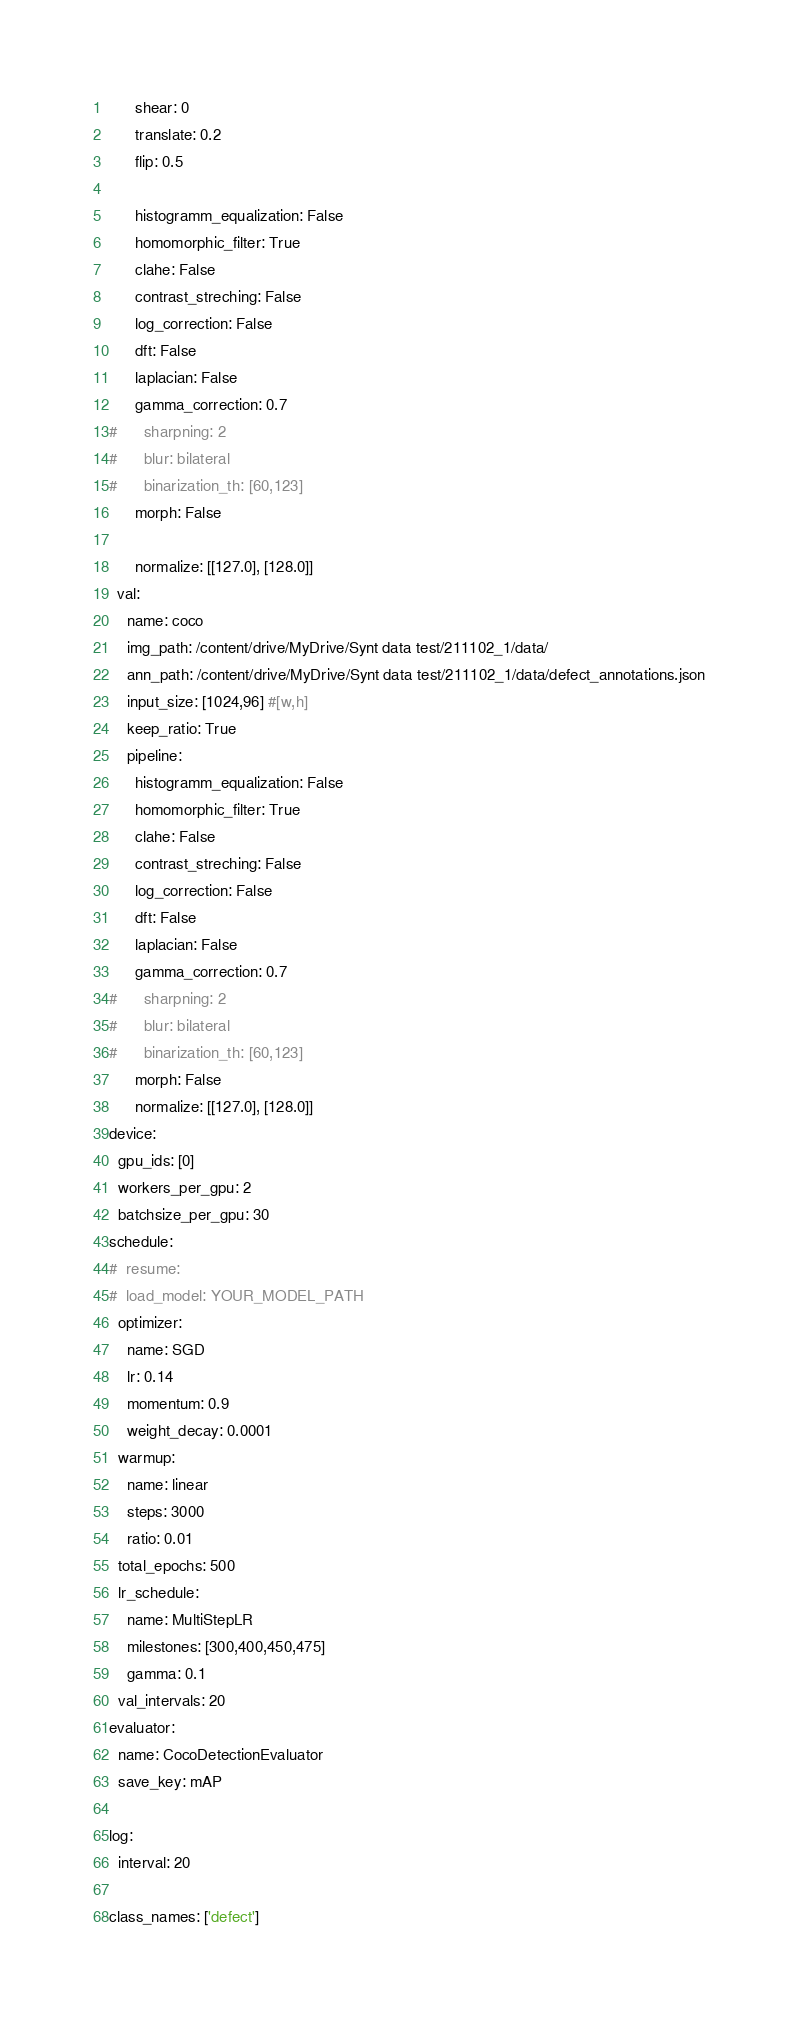Convert code to text. <code><loc_0><loc_0><loc_500><loc_500><_YAML_>      shear: 0
      translate: 0.2
      flip: 0.5
      
      histogramm_equalization: False
      homomorphic_filter: True
      clahe: False
      contrast_streching: False
      log_correction: False
      dft: False
      laplacian: False
      gamma_correction: 0.7
#      sharpning: 2
#      blur: bilateral
#      binarization_th: [60,123]
      morph: False

      normalize: [[127.0], [128.0]]
  val:
    name: coco
    img_path: /content/drive/MyDrive/Synt data test/211102_1/data/
    ann_path: /content/drive/MyDrive/Synt data test/211102_1/data/defect_annotations.json
    input_size: [1024,96] #[w,h]
    keep_ratio: True
    pipeline:
      histogramm_equalization: False
      homomorphic_filter: True
      clahe: False
      contrast_streching: False
      log_correction: False
      dft: False
      laplacian: False
      gamma_correction: 0.7
#      sharpning: 2
#      blur: bilateral
#      binarization_th: [60,123]
      morph: False
      normalize: [[127.0], [128.0]]
device:
  gpu_ids: [0]
  workers_per_gpu: 2
  batchsize_per_gpu: 30
schedule:
#  resume:
#  load_model: YOUR_MODEL_PATH
  optimizer:
    name: SGD
    lr: 0.14
    momentum: 0.9
    weight_decay: 0.0001
  warmup:
    name: linear
    steps: 3000
    ratio: 0.01
  total_epochs: 500
  lr_schedule:
    name: MultiStepLR
    milestones: [300,400,450,475]
    gamma: 0.1
  val_intervals: 20
evaluator:
  name: CocoDetectionEvaluator
  save_key: mAP

log:
  interval: 20

class_names: ['defect']
</code> 